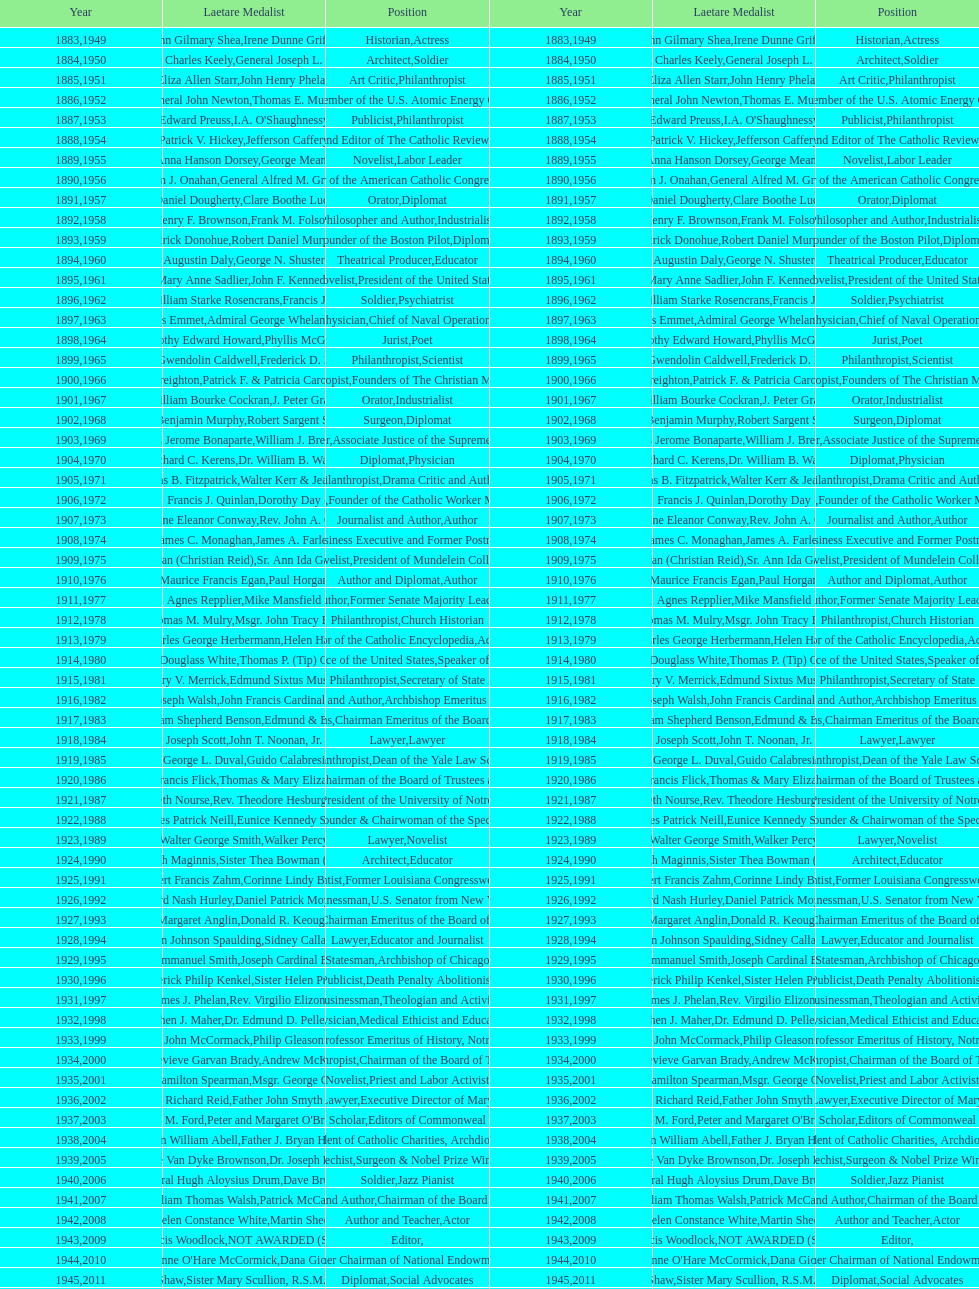How many laetare medal awardees have held a position as a diplomat? 8. 